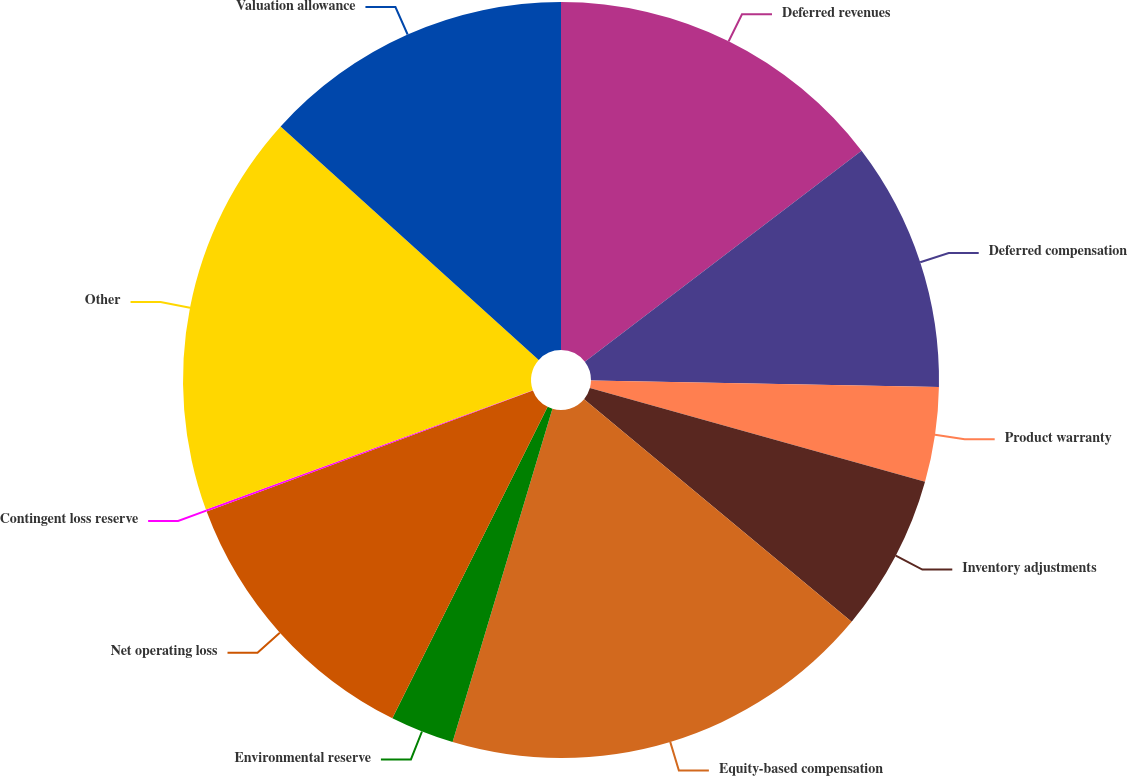Convert chart to OTSL. <chart><loc_0><loc_0><loc_500><loc_500><pie_chart><fcel>Deferred revenues<fcel>Deferred compensation<fcel>Product warranty<fcel>Inventory adjustments<fcel>Equity-based compensation<fcel>Environmental reserve<fcel>Net operating loss<fcel>Contingent loss reserve<fcel>Other<fcel>Valuation allowance<nl><fcel>14.63%<fcel>10.66%<fcel>4.05%<fcel>6.7%<fcel>18.59%<fcel>2.73%<fcel>11.98%<fcel>0.09%<fcel>17.27%<fcel>13.3%<nl></chart> 